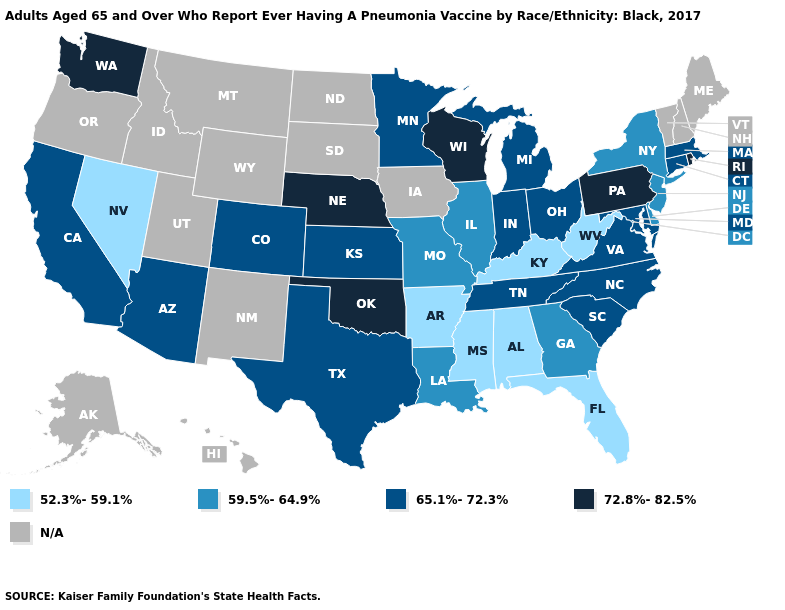What is the value of Oregon?
Be succinct. N/A. Name the states that have a value in the range 52.3%-59.1%?
Short answer required. Alabama, Arkansas, Florida, Kentucky, Mississippi, Nevada, West Virginia. What is the value of Vermont?
Write a very short answer. N/A. Which states have the lowest value in the USA?
Keep it brief. Alabama, Arkansas, Florida, Kentucky, Mississippi, Nevada, West Virginia. What is the value of Florida?
Write a very short answer. 52.3%-59.1%. Which states hav the highest value in the South?
Quick response, please. Oklahoma. Does Missouri have the lowest value in the MidWest?
Concise answer only. Yes. Which states hav the highest value in the MidWest?
Give a very brief answer. Nebraska, Wisconsin. Is the legend a continuous bar?
Write a very short answer. No. Which states have the lowest value in the USA?
Keep it brief. Alabama, Arkansas, Florida, Kentucky, Mississippi, Nevada, West Virginia. Name the states that have a value in the range N/A?
Concise answer only. Alaska, Hawaii, Idaho, Iowa, Maine, Montana, New Hampshire, New Mexico, North Dakota, Oregon, South Dakota, Utah, Vermont, Wyoming. Name the states that have a value in the range 52.3%-59.1%?
Write a very short answer. Alabama, Arkansas, Florida, Kentucky, Mississippi, Nevada, West Virginia. What is the value of Iowa?
Keep it brief. N/A. 